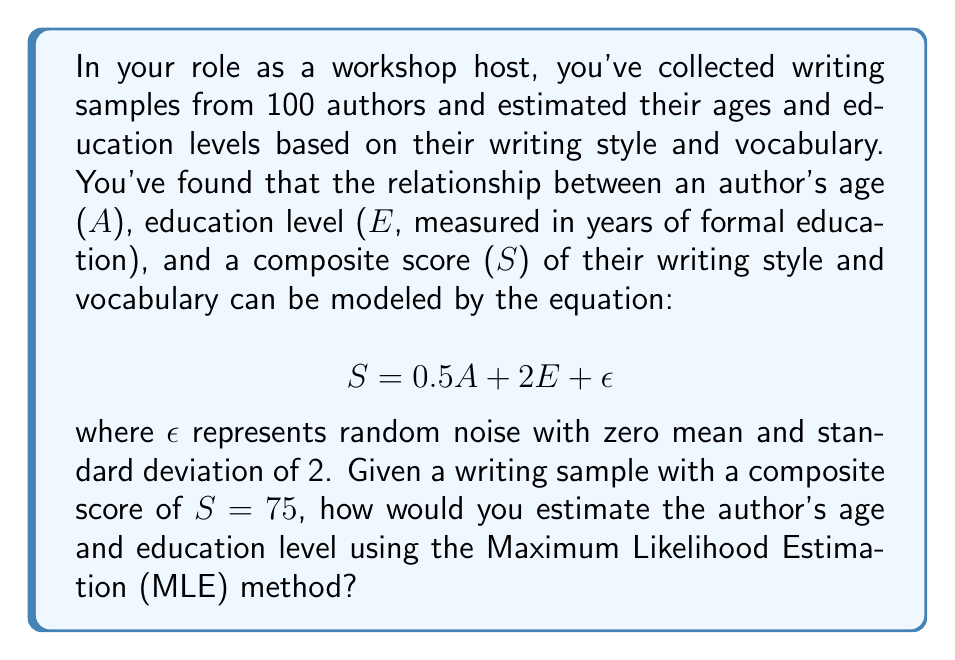Help me with this question. To solve this inverse problem using Maximum Likelihood Estimation (MLE), we'll follow these steps:

1) The likelihood function for this problem, assuming Gaussian noise, is:

   $$ L(A, E | S) = \frac{1}{\sqrt{2\pi\sigma^2}} \exp\left(-\frac{(S - (0.5A + 2E))^2}{2\sigma^2}\right) $$

   where $\sigma = 2$ is the standard deviation of the noise.

2) To maximize the likelihood, we'll minimize the negative log-likelihood:

   $$ -\log L(A, E | S) = \frac{1}{2}\log(2\pi\sigma^2) + \frac{(S - (0.5A + 2E))^2}{2\sigma^2} $$

3) To find the MLE estimates, we set the partial derivatives with respect to $A$ and $E$ to zero:

   $$ \frac{\partial(-\log L)}{\partial A} = -\frac{0.5(S - (0.5A + 2E))}{2\sigma^2} = 0 $$
   $$ \frac{\partial(-\log L)}{\partial E} = -\frac{2(S - (0.5A + 2E))}{2\sigma^2} = 0 $$

4) Solving these equations:

   $$ S - (0.5A + 2E) = 0 $$
   $$ S = 0.5A + 2E $$

5) We have one equation and two unknowns. This is an underdetermined system, meaning there are infinitely many solutions. We can express $E$ in terms of $A$:

   $$ E = \frac{S - 0.5A}{2} $$

6) Substituting the given value $S = 75$:

   $$ E = \frac{75 - 0.5A}{2} = 37.5 - 0.25A $$

This equation represents the set of all possible (A, E) pairs that maximize the likelihood for the given score.
Answer: $E = 37.5 - 0.25A$, where $A$ is age and $E$ is education level in years. 